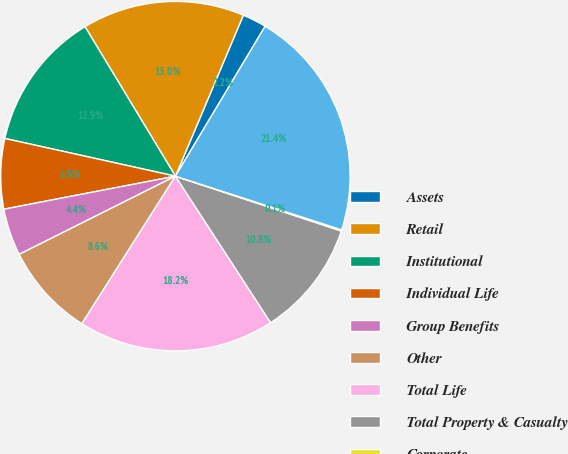Convert chart to OTSL. <chart><loc_0><loc_0><loc_500><loc_500><pie_chart><fcel>Assets<fcel>Retail<fcel>Institutional<fcel>Individual Life<fcel>Group Benefits<fcel>Other<fcel>Total Life<fcel>Total Property & Casualty<fcel>Corporate<fcel>Total Assets<nl><fcel>2.23%<fcel>15.01%<fcel>12.88%<fcel>6.49%<fcel>4.36%<fcel>8.62%<fcel>18.16%<fcel>10.75%<fcel>0.11%<fcel>21.39%<nl></chart> 